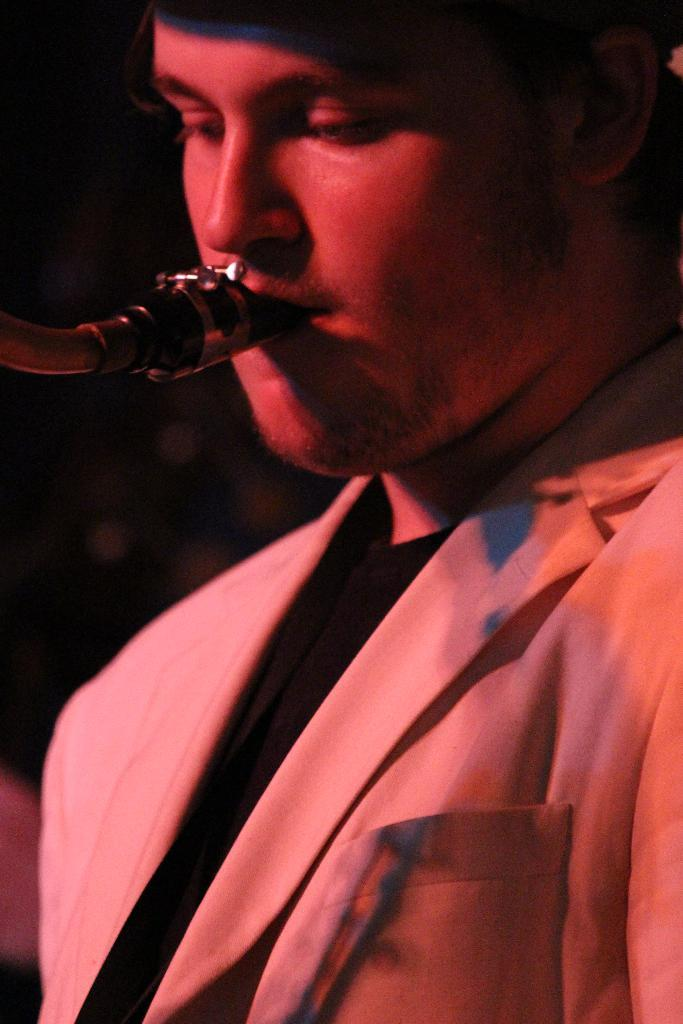What is the main subject of the image? There is a person in the image. What is the person doing in the image? The person is playing a musical instrument. Can you describe the background of the image? The background of the image is dark. What is the person's belief about the existence of thumb-sized creatures in the image? There is no mention of beliefs or thumb-sized creatures in the image, so it cannot be determined from the image. 